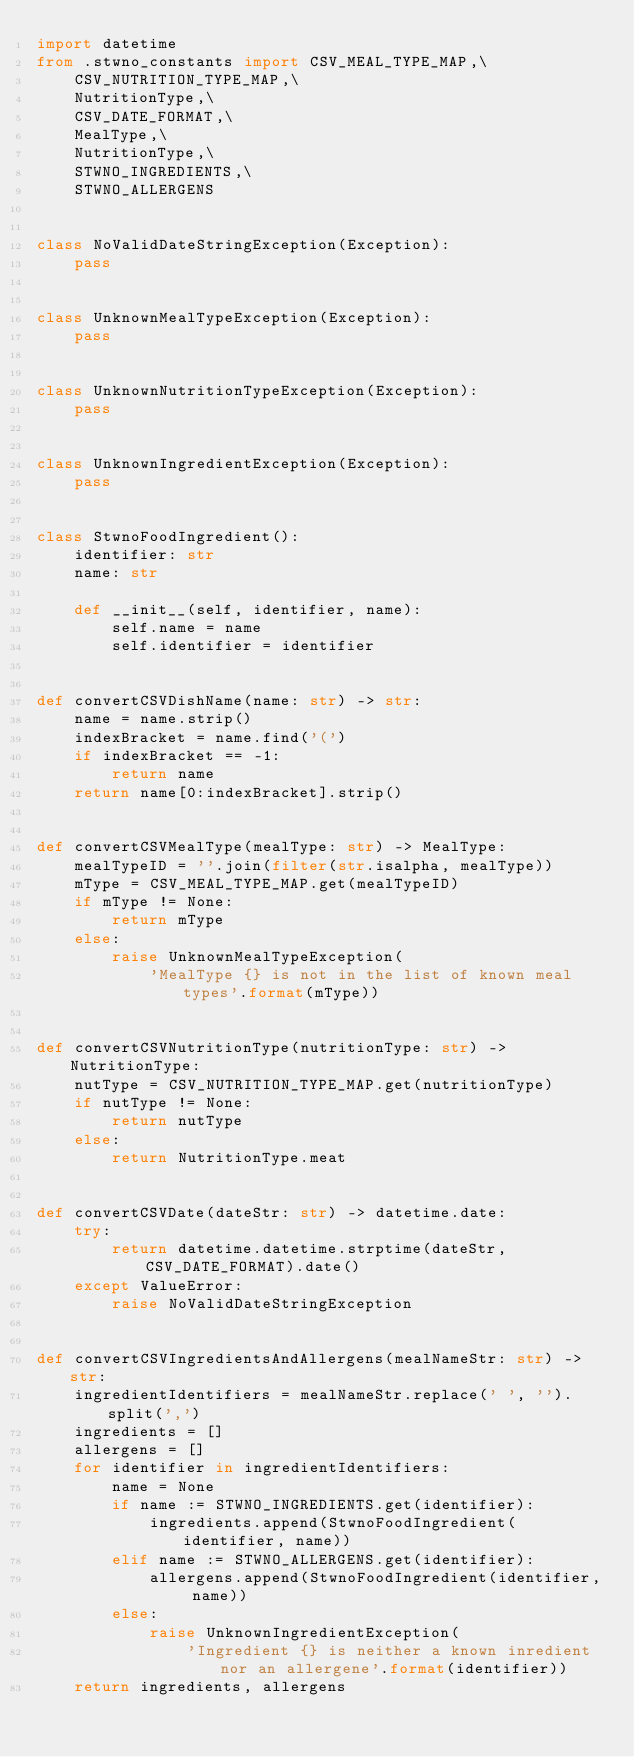Convert code to text. <code><loc_0><loc_0><loc_500><loc_500><_Python_>import datetime
from .stwno_constants import CSV_MEAL_TYPE_MAP,\
    CSV_NUTRITION_TYPE_MAP,\
    NutritionType,\
    CSV_DATE_FORMAT,\
    MealType,\
    NutritionType,\
    STWNO_INGREDIENTS,\
    STWNO_ALLERGENS


class NoValidDateStringException(Exception):
    pass


class UnknownMealTypeException(Exception):
    pass


class UnknownNutritionTypeException(Exception):
    pass


class UnknownIngredientException(Exception):
    pass


class StwnoFoodIngredient():
    identifier: str
    name: str

    def __init__(self, identifier, name):
        self.name = name
        self.identifier = identifier


def convertCSVDishName(name: str) -> str:
    name = name.strip()
    indexBracket = name.find('(')
    if indexBracket == -1:
        return name
    return name[0:indexBracket].strip()


def convertCSVMealType(mealType: str) -> MealType:
    mealTypeID = ''.join(filter(str.isalpha, mealType))
    mType = CSV_MEAL_TYPE_MAP.get(mealTypeID)
    if mType != None:
        return mType
    else:
        raise UnknownMealTypeException(
            'MealType {} is not in the list of known meal types'.format(mType))


def convertCSVNutritionType(nutritionType: str) -> NutritionType:
    nutType = CSV_NUTRITION_TYPE_MAP.get(nutritionType)
    if nutType != None:
        return nutType
    else:
        return NutritionType.meat


def convertCSVDate(dateStr: str) -> datetime.date:
    try:
        return datetime.datetime.strptime(dateStr, CSV_DATE_FORMAT).date()
    except ValueError:
        raise NoValidDateStringException


def convertCSVIngredientsAndAllergens(mealNameStr: str) -> str:
    ingredientIdentifiers = mealNameStr.replace(' ', '').split(',')
    ingredients = []
    allergens = []
    for identifier in ingredientIdentifiers:
        name = None
        if name := STWNO_INGREDIENTS.get(identifier):
            ingredients.append(StwnoFoodIngredient(identifier, name))
        elif name := STWNO_ALLERGENS.get(identifier):
            allergens.append(StwnoFoodIngredient(identifier, name))
        else:
            raise UnknownIngredientException(
                'Ingredient {} is neither a known inredient nor an allergene'.format(identifier))
    return ingredients, allergens

</code> 